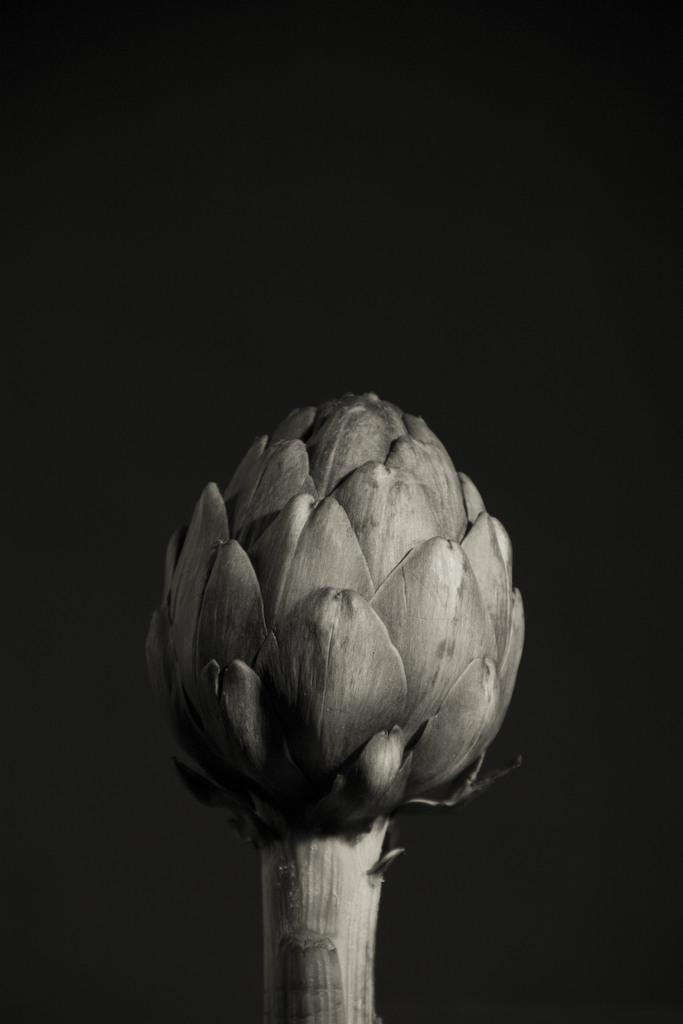What is the main subject of the image? There is an Artichoke in the image. Can you describe the background of the image? The background of the image is dark. How many people are smiling in the image? There are no people present in the image, so it is not possible to determine how many people might be smiling. 